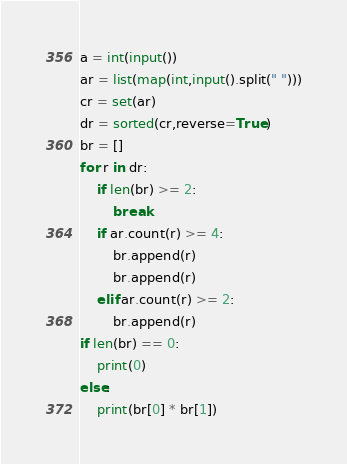Convert code to text. <code><loc_0><loc_0><loc_500><loc_500><_Python_>a = int(input())
ar = list(map(int,input().split(" ")))
cr = set(ar)
dr = sorted(cr,reverse=True)
br = []
for r in dr:
    if len(br) >= 2:
        break
    if ar.count(r) >= 4:
        br.append(r)
        br.append(r)
    elif ar.count(r) >= 2:
        br.append(r)
if len(br) == 0:
    print(0)
else:
    print(br[0] * br[1])</code> 